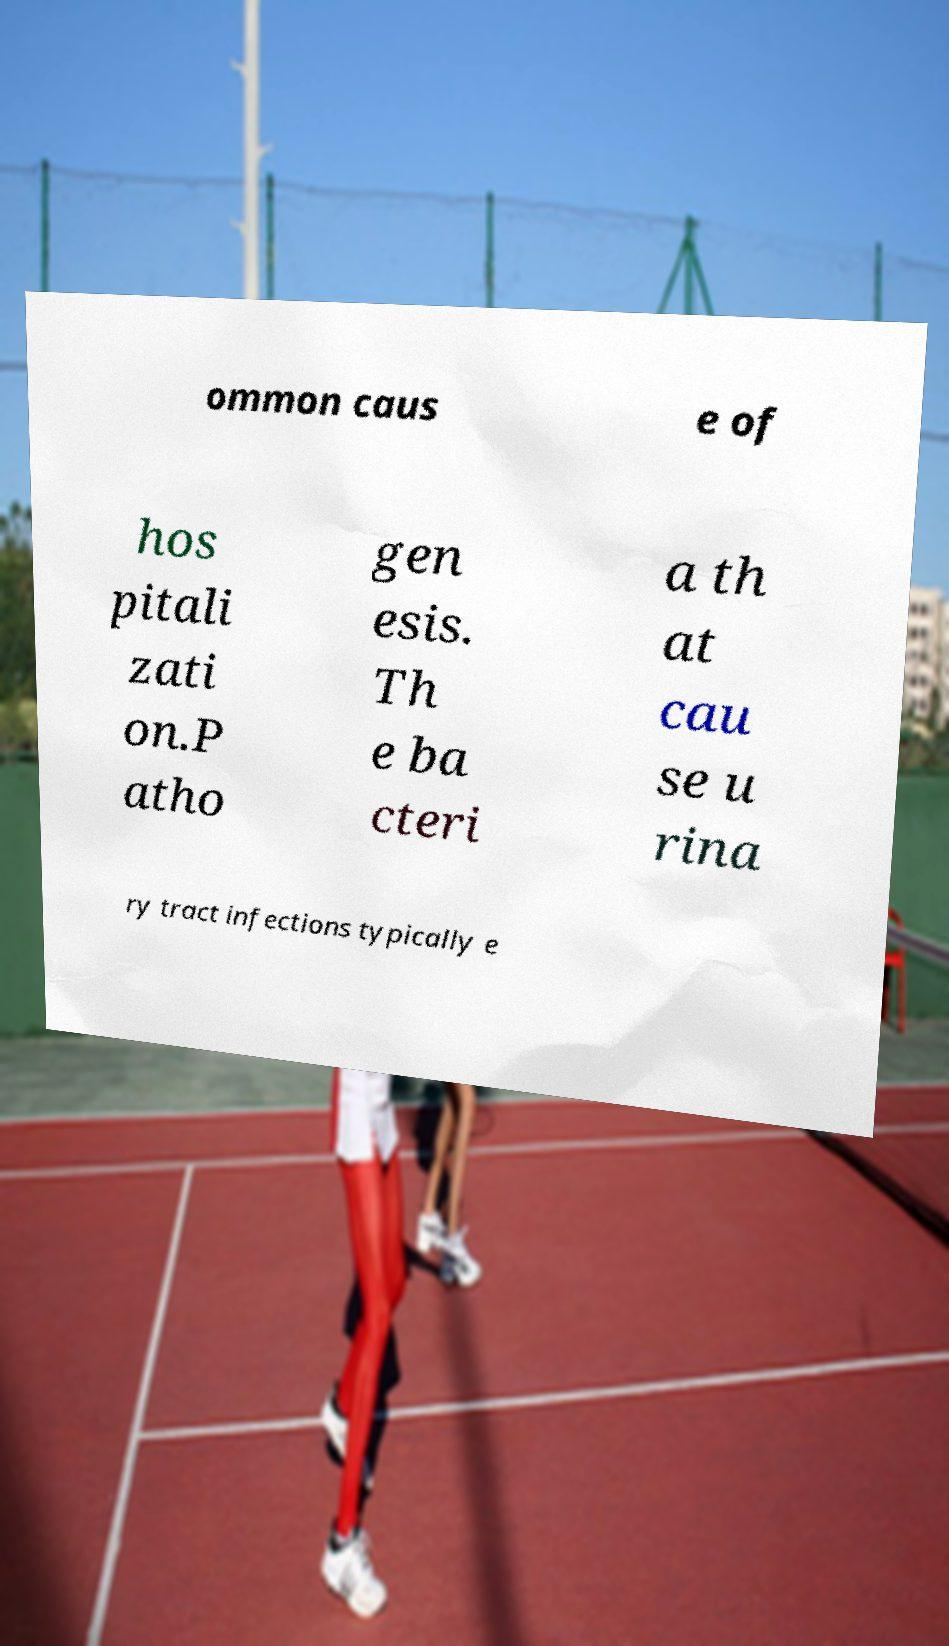Could you assist in decoding the text presented in this image and type it out clearly? ommon caus e of hos pitali zati on.P atho gen esis. Th e ba cteri a th at cau se u rina ry tract infections typically e 